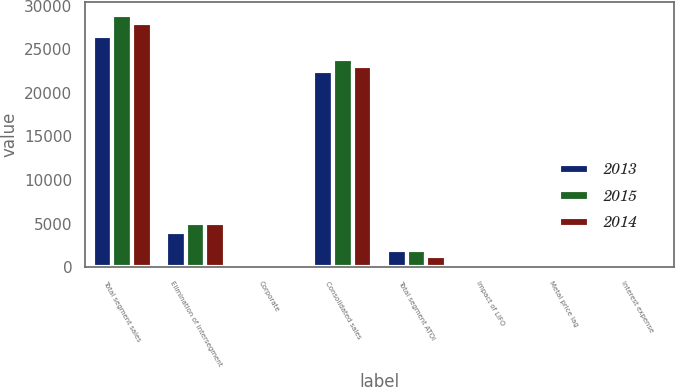Convert chart to OTSL. <chart><loc_0><loc_0><loc_500><loc_500><stacked_bar_chart><ecel><fcel>Total segment sales<fcel>Elimination of intersegment<fcel>Corporate<fcel>Consolidated sales<fcel>Total segment ATOI<fcel>Impact of LIFO<fcel>Metal price lag<fcel>Interest expense<nl><fcel>2013<fcel>26490<fcel>3982<fcel>26<fcel>22534<fcel>1906<fcel>136<fcel>133<fcel>324<nl><fcel>2015<fcel>28955<fcel>5057<fcel>8<fcel>23906<fcel>1968<fcel>54<fcel>78<fcel>308<nl><fcel>2014<fcel>28067<fcel>5034<fcel>1<fcel>23032<fcel>1267<fcel>52<fcel>45<fcel>294<nl></chart> 